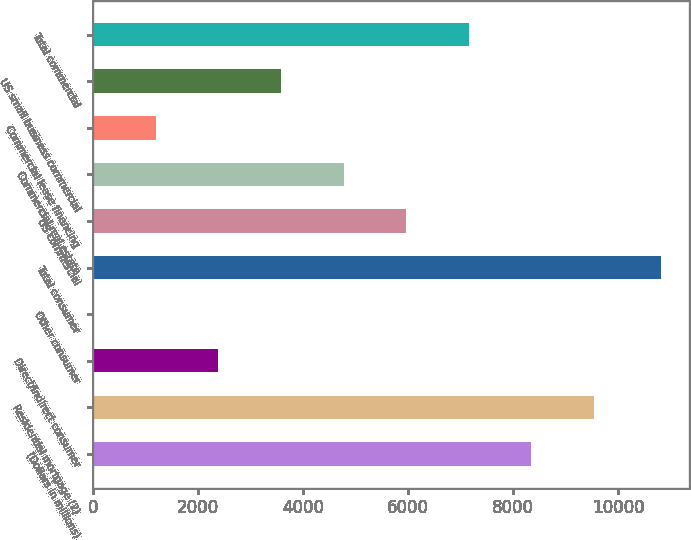<chart> <loc_0><loc_0><loc_500><loc_500><bar_chart><fcel>(Dollars in millions)<fcel>Residential mortgage (2)<fcel>Direct/Indirect consumer<fcel>Other consumer<fcel>Total consumer<fcel>US commercial<fcel>Commercial real estate<fcel>Commercial lease financing<fcel>US small business commercial<fcel>Total commercial<nl><fcel>8352.7<fcel>9545.8<fcel>2387.2<fcel>1<fcel>10819<fcel>5966.5<fcel>4773.4<fcel>1194.1<fcel>3580.3<fcel>7159.6<nl></chart> 